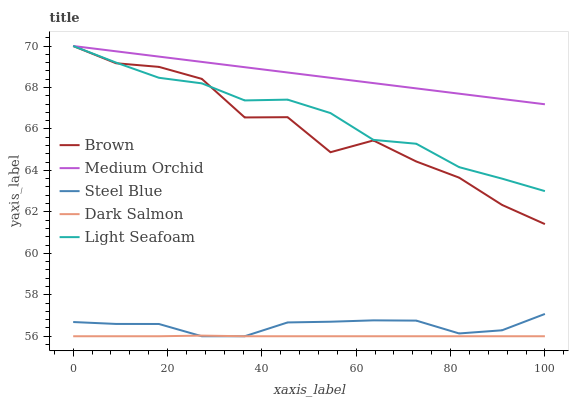Does Dark Salmon have the minimum area under the curve?
Answer yes or no. Yes. Does Medium Orchid have the maximum area under the curve?
Answer yes or no. Yes. Does Steel Blue have the minimum area under the curve?
Answer yes or no. No. Does Steel Blue have the maximum area under the curve?
Answer yes or no. No. Is Medium Orchid the smoothest?
Answer yes or no. Yes. Is Brown the roughest?
Answer yes or no. Yes. Is Steel Blue the smoothest?
Answer yes or no. No. Is Steel Blue the roughest?
Answer yes or no. No. Does Steel Blue have the lowest value?
Answer yes or no. Yes. Does Medium Orchid have the lowest value?
Answer yes or no. No. Does Light Seafoam have the highest value?
Answer yes or no. Yes. Does Steel Blue have the highest value?
Answer yes or no. No. Is Steel Blue less than Brown?
Answer yes or no. Yes. Is Medium Orchid greater than Dark Salmon?
Answer yes or no. Yes. Does Brown intersect Medium Orchid?
Answer yes or no. Yes. Is Brown less than Medium Orchid?
Answer yes or no. No. Is Brown greater than Medium Orchid?
Answer yes or no. No. Does Steel Blue intersect Brown?
Answer yes or no. No. 